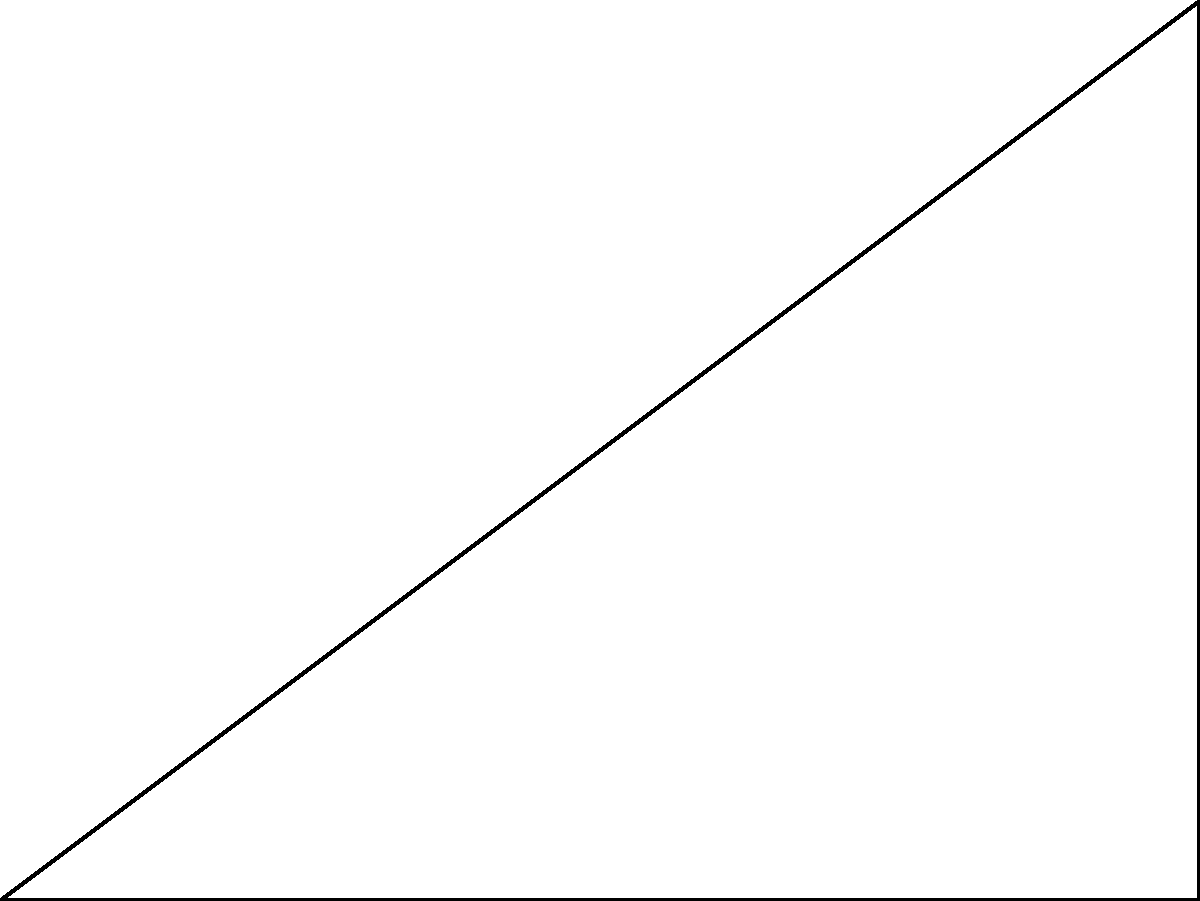As a mentor working with underprivileged children, you want to teach them about practical applications of trigonometry. You decide to use the school building as an example. Standing 30 meters away from the base of the building, you measure the angle of elevation to the top of the building to be $\theta$. If the height of the building is 22.5 meters, what is the angle of elevation $\theta$ to the nearest degree? Let's approach this step-by-step:

1) We have a right triangle where:
   - The adjacent side (ground distance) is 30 meters
   - The opposite side (height of the building) is 22.5 meters
   - We need to find the angle $\theta$

2) In a right triangle, $\tan(\theta) = \frac{\text{opposite}}{\text{adjacent}}$

3) Substituting our values:

   $\tan(\theta) = \frac{22.5}{30}$

4) To find $\theta$, we need to use the inverse tangent (arctan or $\tan^{-1}$):

   $\theta = \tan^{-1}(\frac{22.5}{30})$

5) Using a calculator:

   $\theta = \tan^{-1}(0.75) \approx 36.87°$

6) Rounding to the nearest degree:

   $\theta \approx 37°$

This practical example demonstrates how trigonometry can be used to measure the height of tall structures without directly measuring them, which can be a valuable lesson for the children.
Answer: 37° 